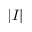<formula> <loc_0><loc_0><loc_500><loc_500>| I |</formula> 